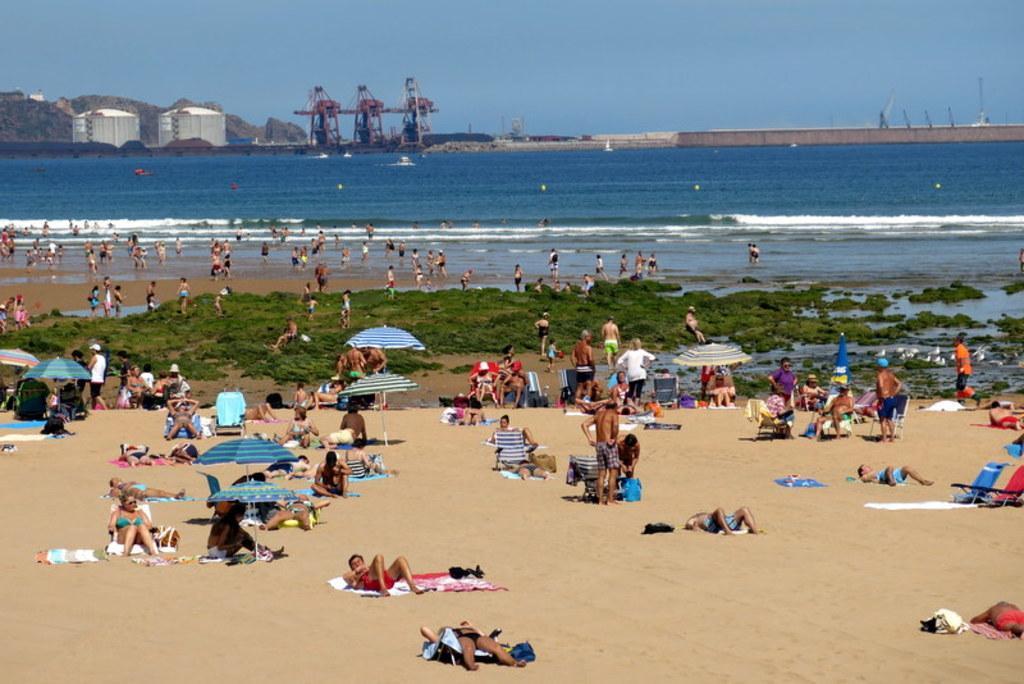How would you summarize this image in a sentence or two? In the foreground of this image, there are group of persons few among them are lying down, few are sitting under the umbrellas and few are standing. In the background, there are persons standing, water, industry and the sky. 